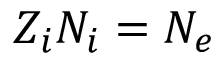Convert formula to latex. <formula><loc_0><loc_0><loc_500><loc_500>Z _ { i } N _ { i } = N _ { e }</formula> 